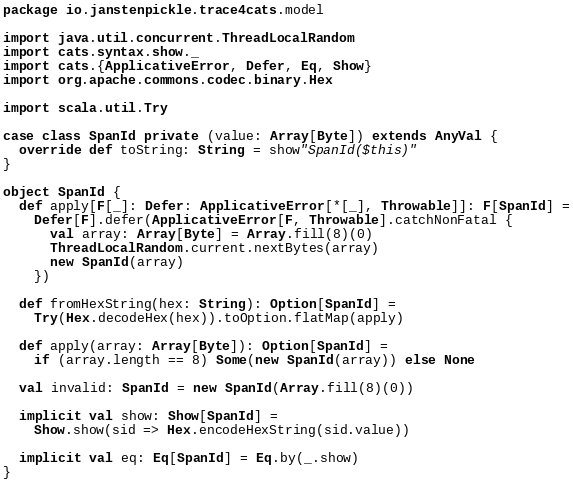<code> <loc_0><loc_0><loc_500><loc_500><_Scala_>package io.janstenpickle.trace4cats.model

import java.util.concurrent.ThreadLocalRandom
import cats.syntax.show._
import cats.{ApplicativeError, Defer, Eq, Show}
import org.apache.commons.codec.binary.Hex

import scala.util.Try

case class SpanId private (value: Array[Byte]) extends AnyVal {
  override def toString: String = show"SpanId($this)"
}

object SpanId {
  def apply[F[_]: Defer: ApplicativeError[*[_], Throwable]]: F[SpanId] =
    Defer[F].defer(ApplicativeError[F, Throwable].catchNonFatal {
      val array: Array[Byte] = Array.fill(8)(0)
      ThreadLocalRandom.current.nextBytes(array)
      new SpanId(array)
    })

  def fromHexString(hex: String): Option[SpanId] =
    Try(Hex.decodeHex(hex)).toOption.flatMap(apply)

  def apply(array: Array[Byte]): Option[SpanId] =
    if (array.length == 8) Some(new SpanId(array)) else None

  val invalid: SpanId = new SpanId(Array.fill(8)(0))

  implicit val show: Show[SpanId] =
    Show.show(sid => Hex.encodeHexString(sid.value))

  implicit val eq: Eq[SpanId] = Eq.by(_.show)
}
</code> 